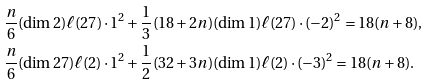<formula> <loc_0><loc_0><loc_500><loc_500>\frac { n } { 6 } ( \dim { 2 } ) \ell ( { 2 7 } ) \cdot 1 ^ { 2 } & + \frac { 1 } { 3 } ( 1 8 + 2 n ) ( \dim { 1 } ) \ell ( { 2 7 } ) \cdot ( - 2 ) ^ { 2 } = 1 8 ( n + 8 ) , \\ \frac { n } { 6 } ( \dim { 2 7 } ) \ell ( { 2 } ) \cdot 1 ^ { 2 } & + \frac { 1 } { 2 } ( 3 2 + 3 n ) ( \dim { 1 } ) \ell ( { 2 } ) \cdot ( - 3 ) ^ { 2 } = 1 8 ( n + 8 ) .</formula> 